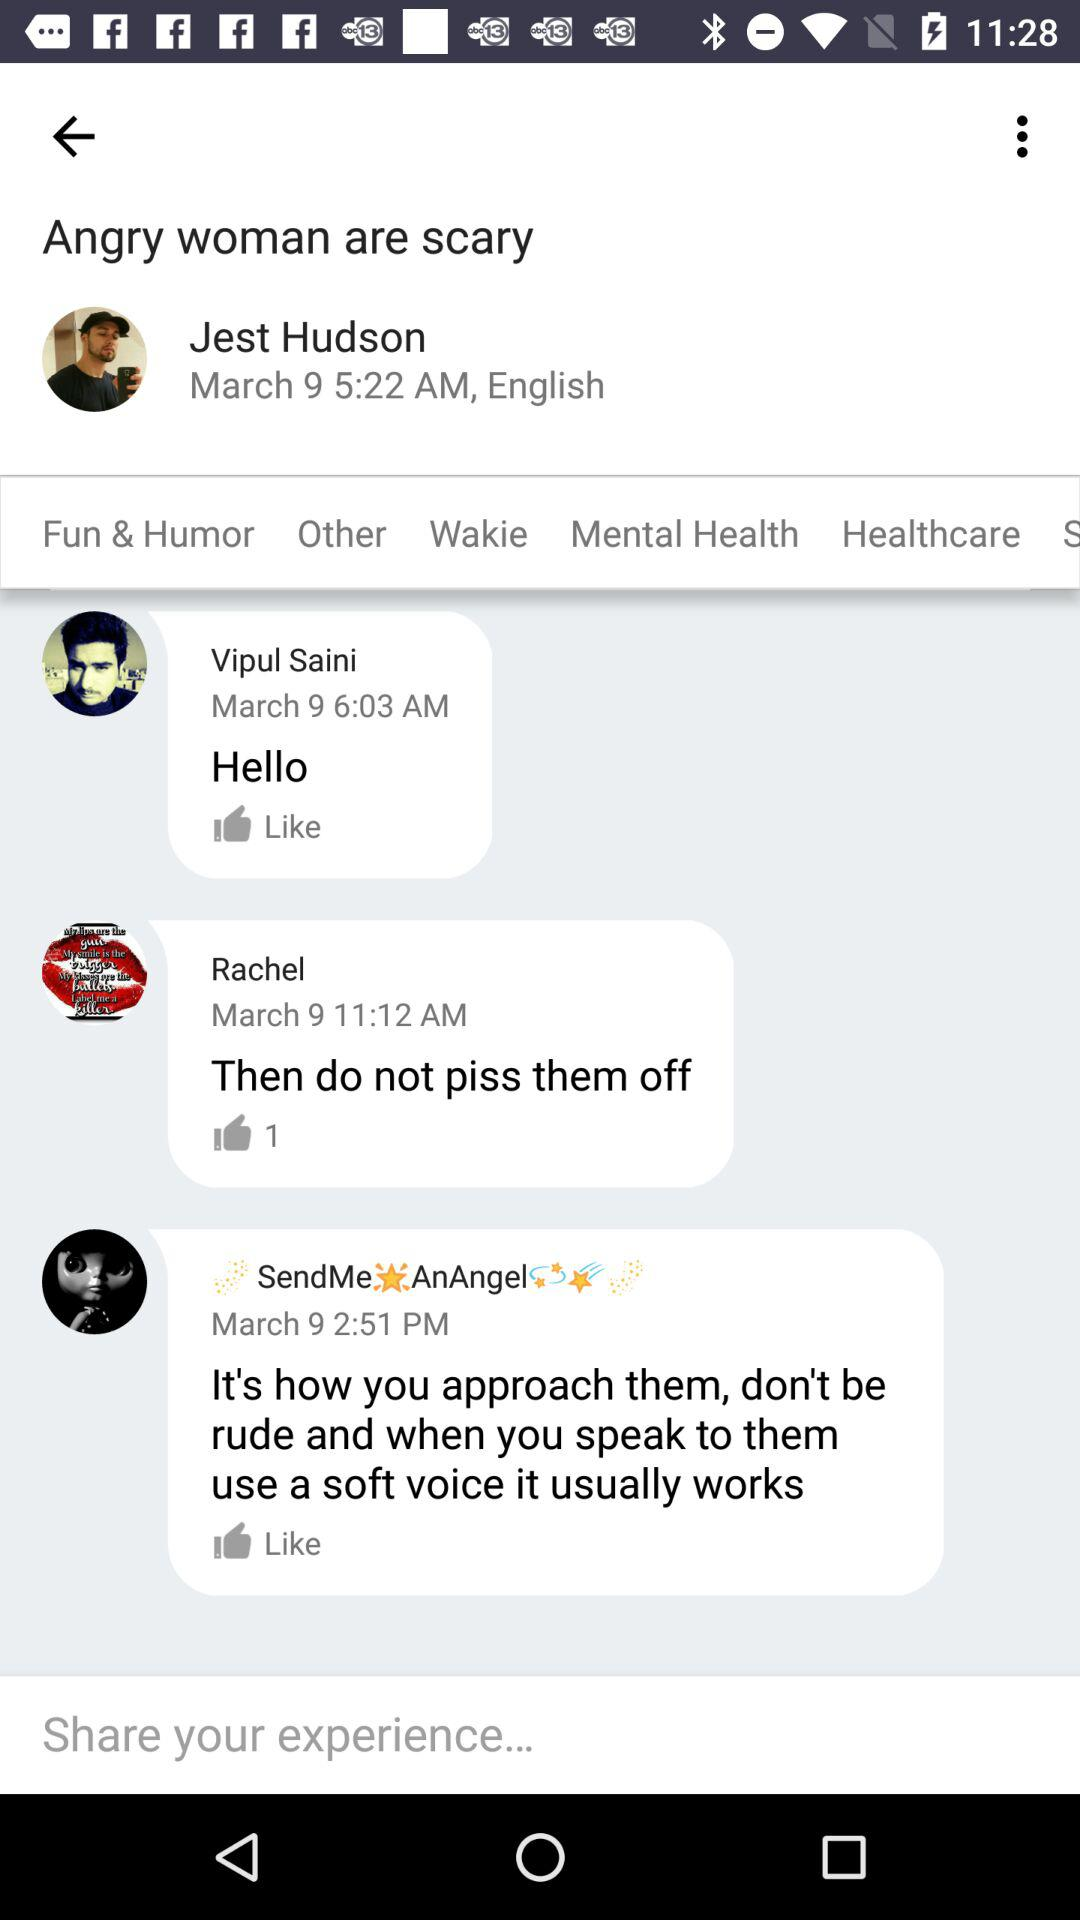What is the date and time of the comment that was posted by Vipul Saini? The date and time of the comment that was posted by Vipul Saini are March 9 and 6:03 AM, respectively. 